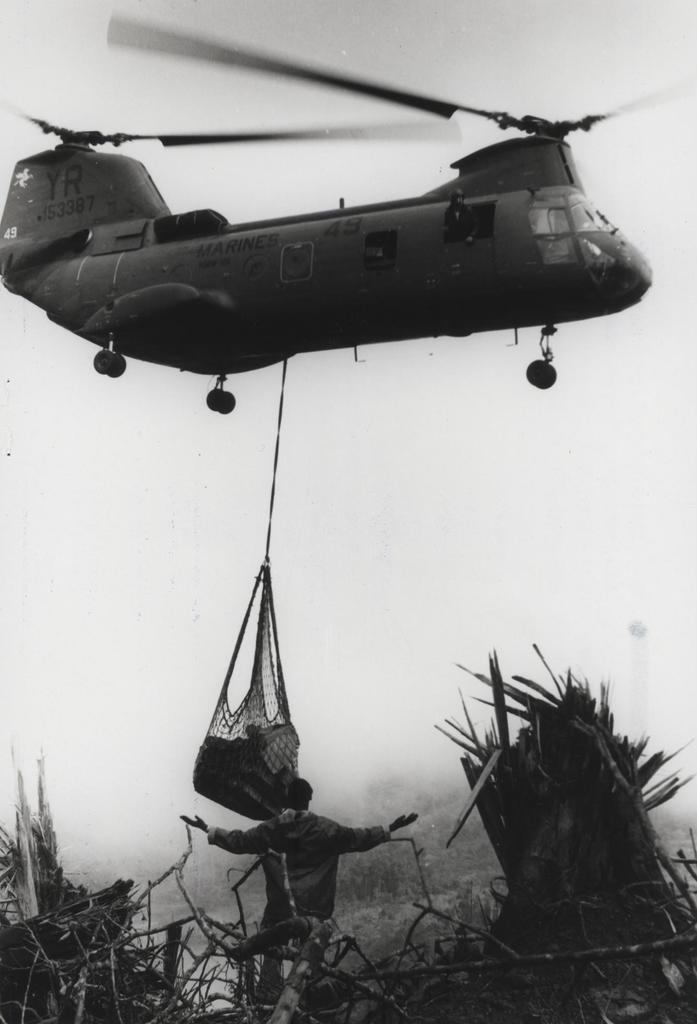How would you summarize this image in a sentence or two? This is a black and white image in this image there is aircraft hanging few items, at the bottom there are few object and there is a man. 